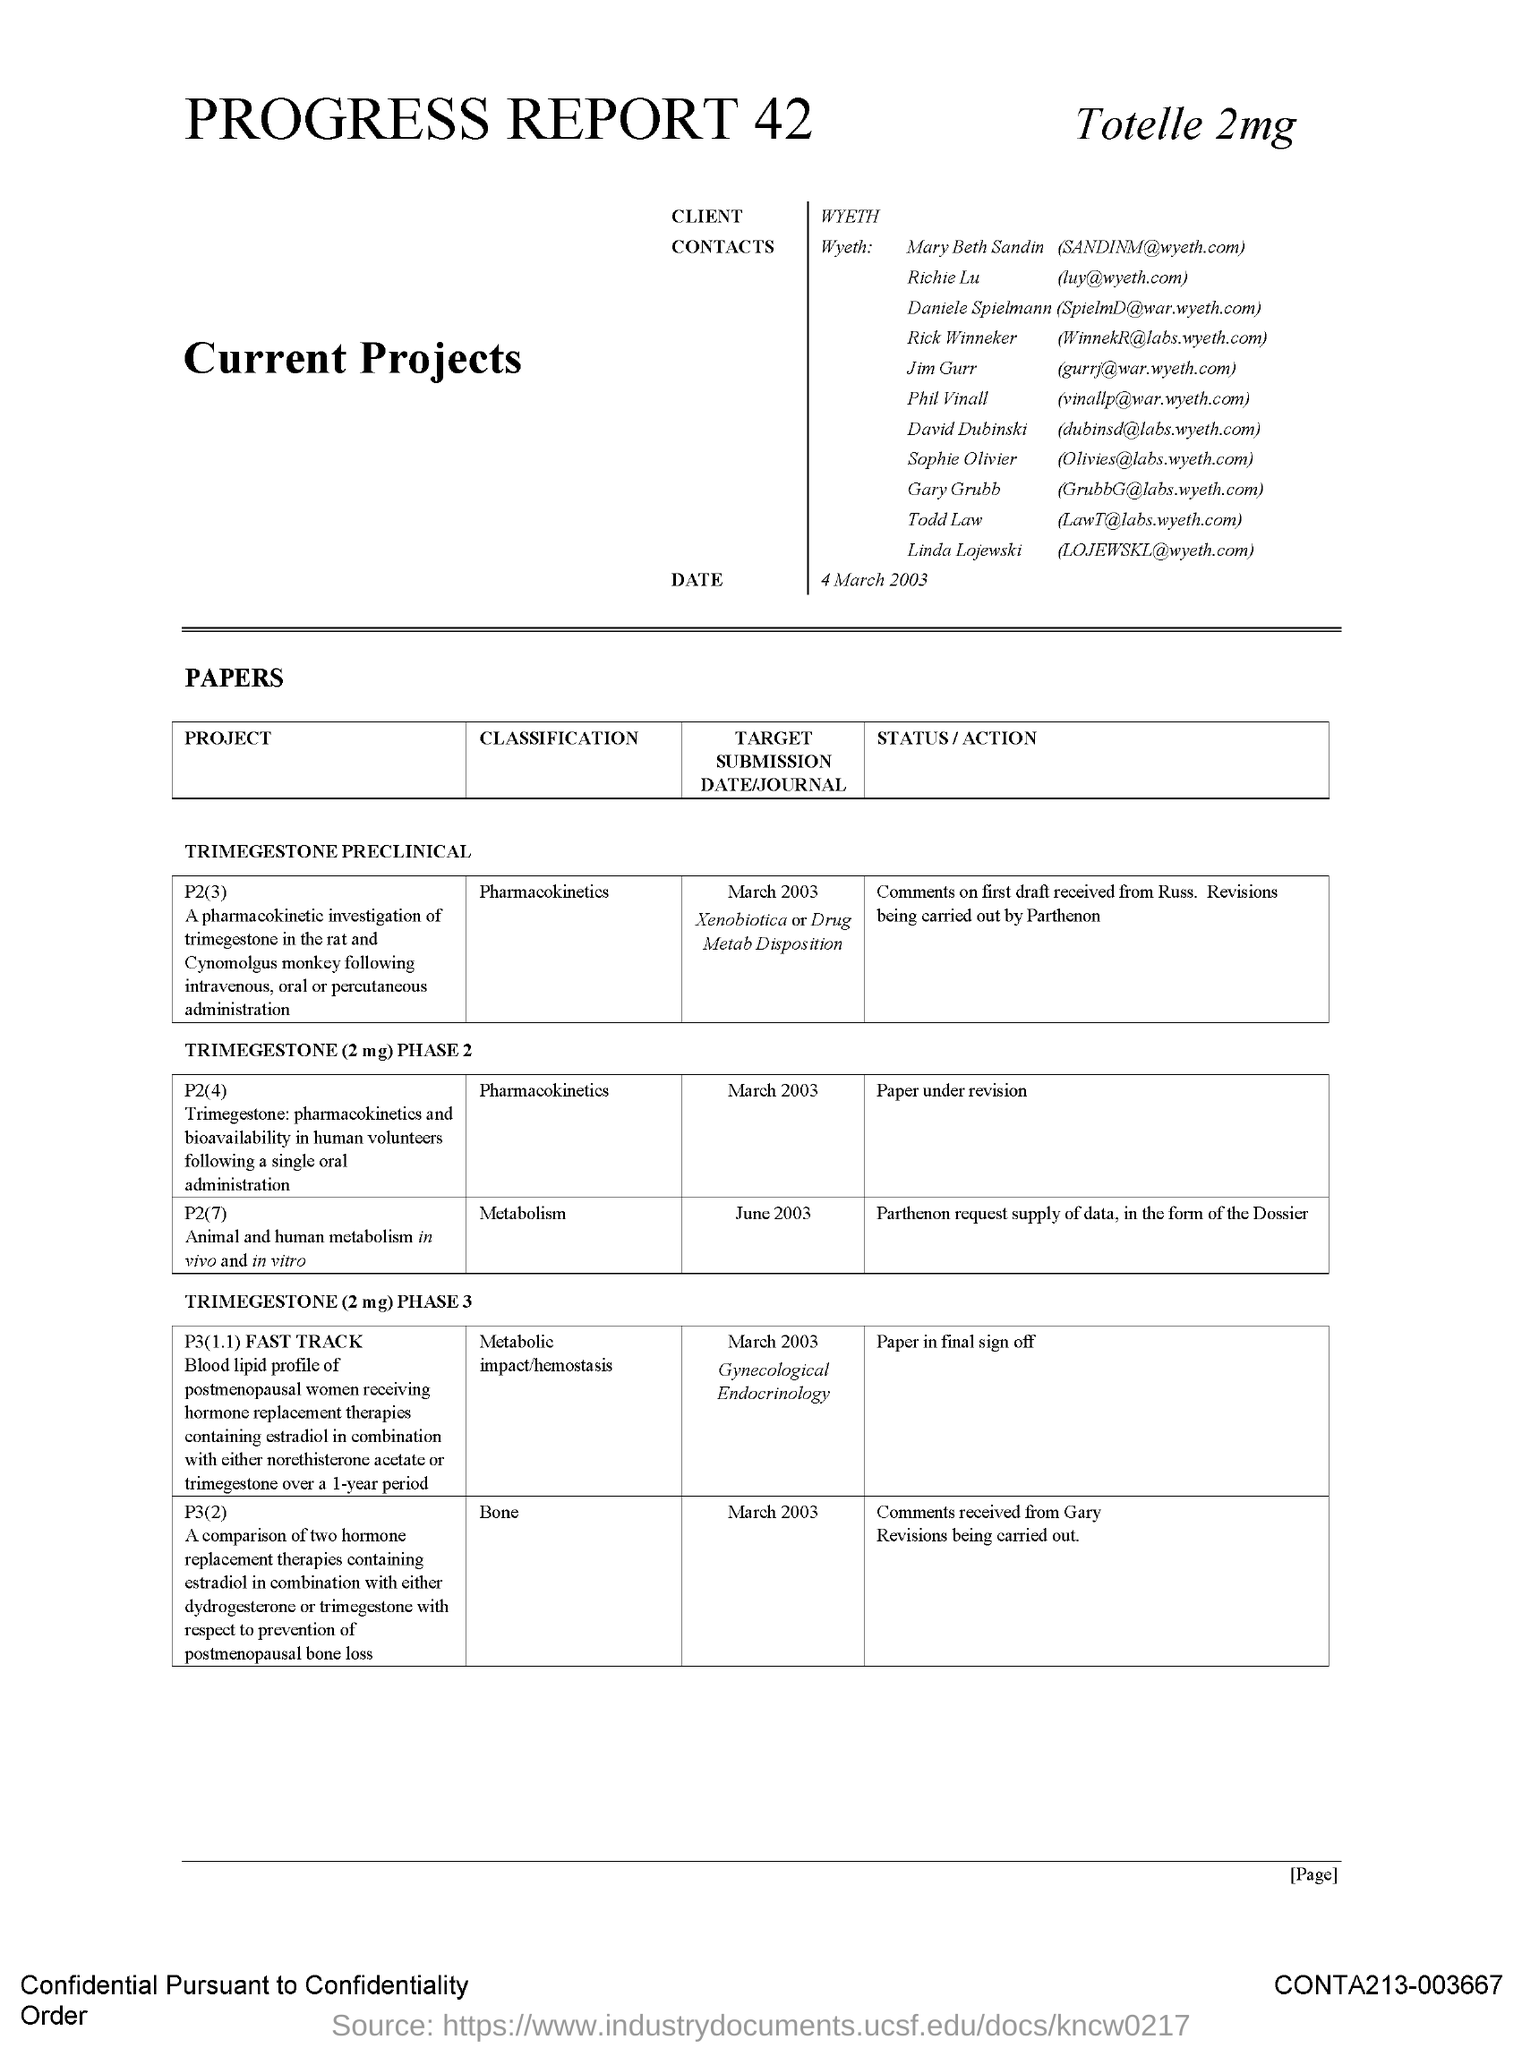What is the classification in p3(2) ?
Keep it short and to the point. Bone. 